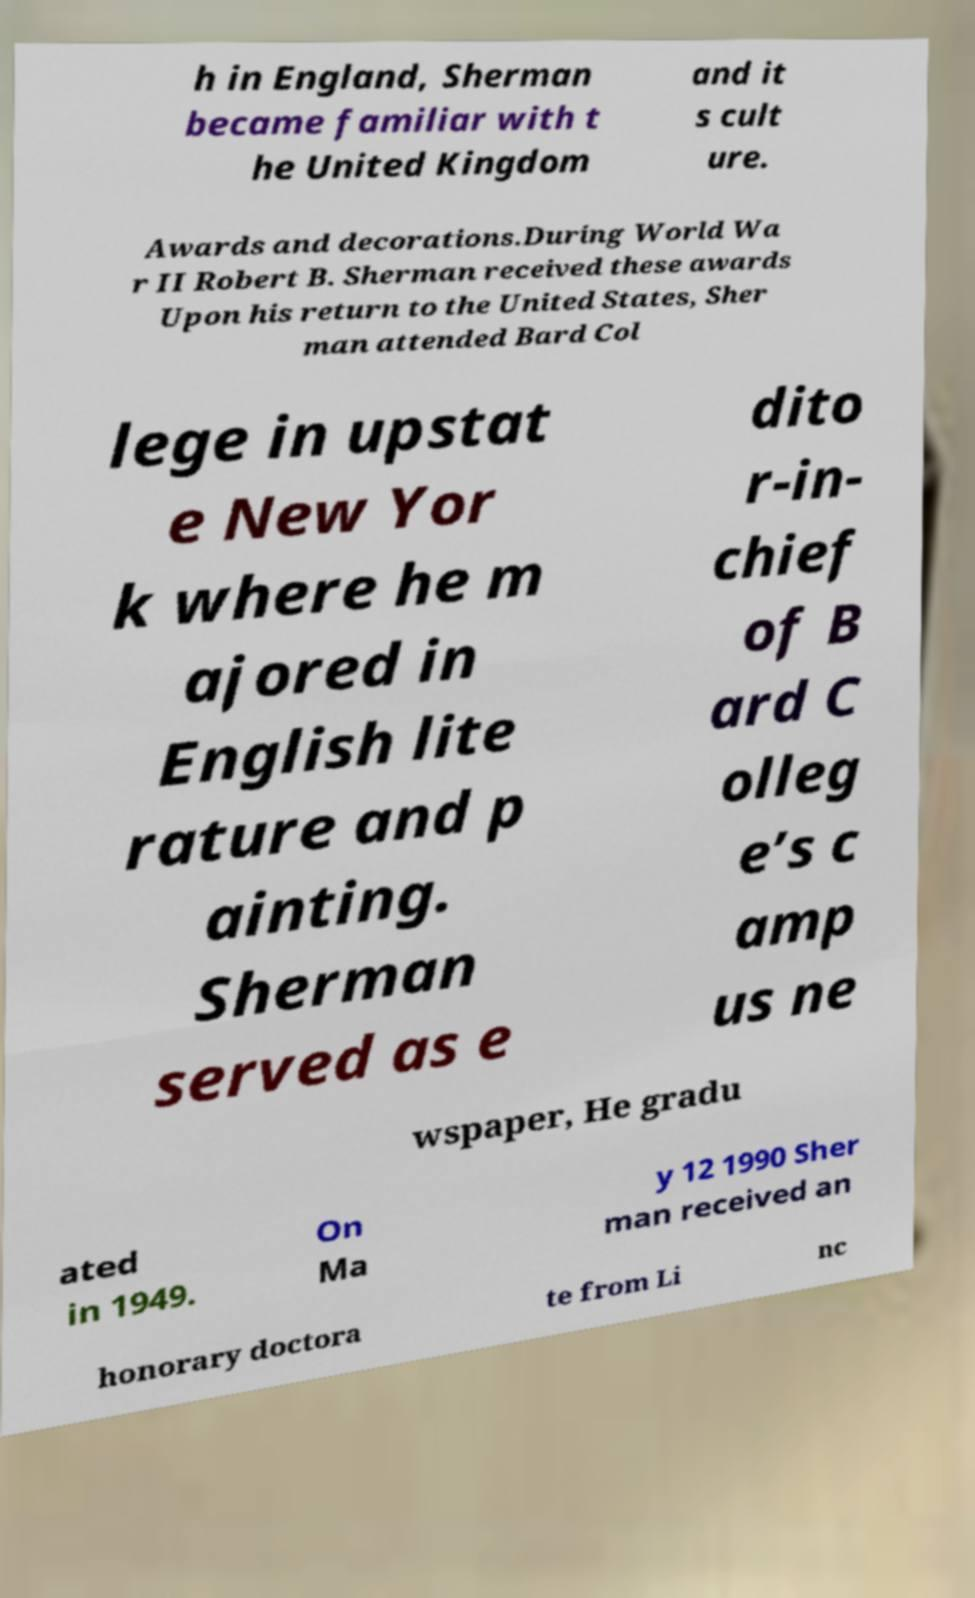What messages or text are displayed in this image? I need them in a readable, typed format. h in England, Sherman became familiar with t he United Kingdom and it s cult ure. Awards and decorations.During World Wa r II Robert B. Sherman received these awards Upon his return to the United States, Sher man attended Bard Col lege in upstat e New Yor k where he m ajored in English lite rature and p ainting. Sherman served as e dito r-in- chief of B ard C olleg e’s c amp us ne wspaper, He gradu ated in 1949. On Ma y 12 1990 Sher man received an honorary doctora te from Li nc 